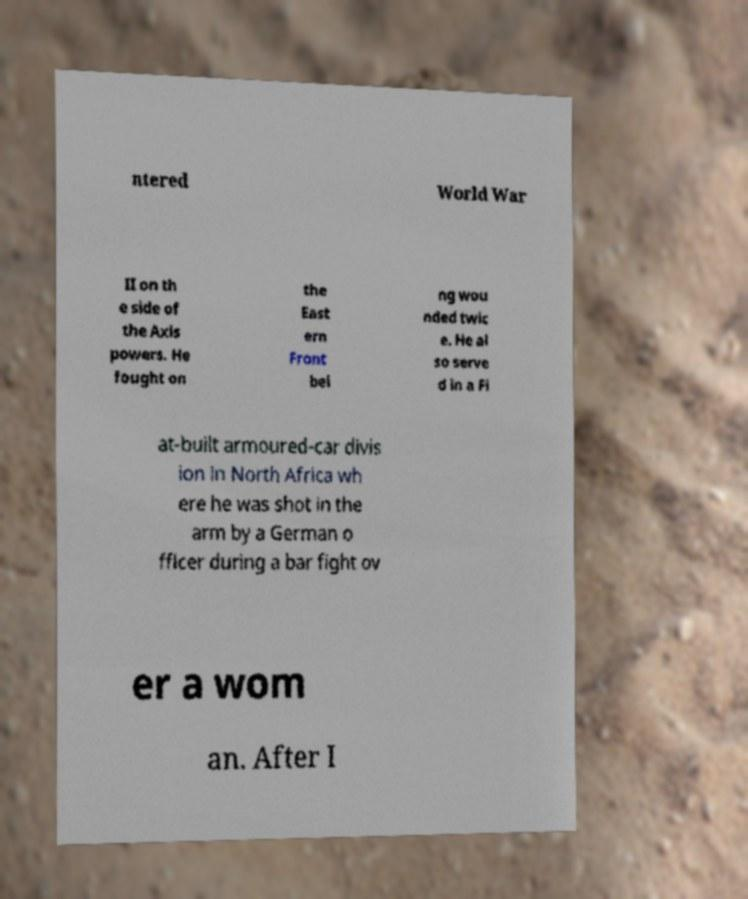For documentation purposes, I need the text within this image transcribed. Could you provide that? ntered World War II on th e side of the Axis powers. He fought on the East ern Front bei ng wou nded twic e. He al so serve d in a Fi at-built armoured-car divis ion in North Africa wh ere he was shot in the arm by a German o fficer during a bar fight ov er a wom an. After I 